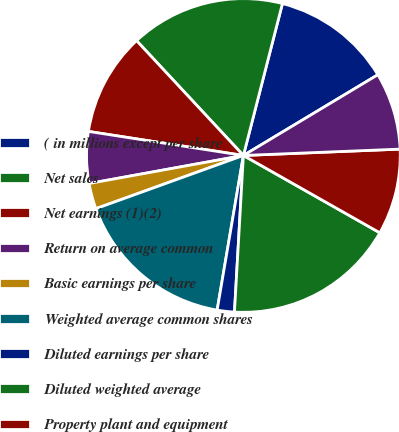Convert chart to OTSL. <chart><loc_0><loc_0><loc_500><loc_500><pie_chart><fcel>( in millions except per share<fcel>Net sales<fcel>Net earnings (1)(2)<fcel>Return on average common<fcel>Basic earnings per share<fcel>Weighted average common shares<fcel>Diluted earnings per share<fcel>Diluted weighted average<fcel>Property plant and equipment<fcel>Depreciation and amortization<nl><fcel>12.39%<fcel>15.93%<fcel>10.62%<fcel>5.31%<fcel>2.65%<fcel>16.81%<fcel>1.77%<fcel>17.7%<fcel>8.85%<fcel>7.96%<nl></chart> 